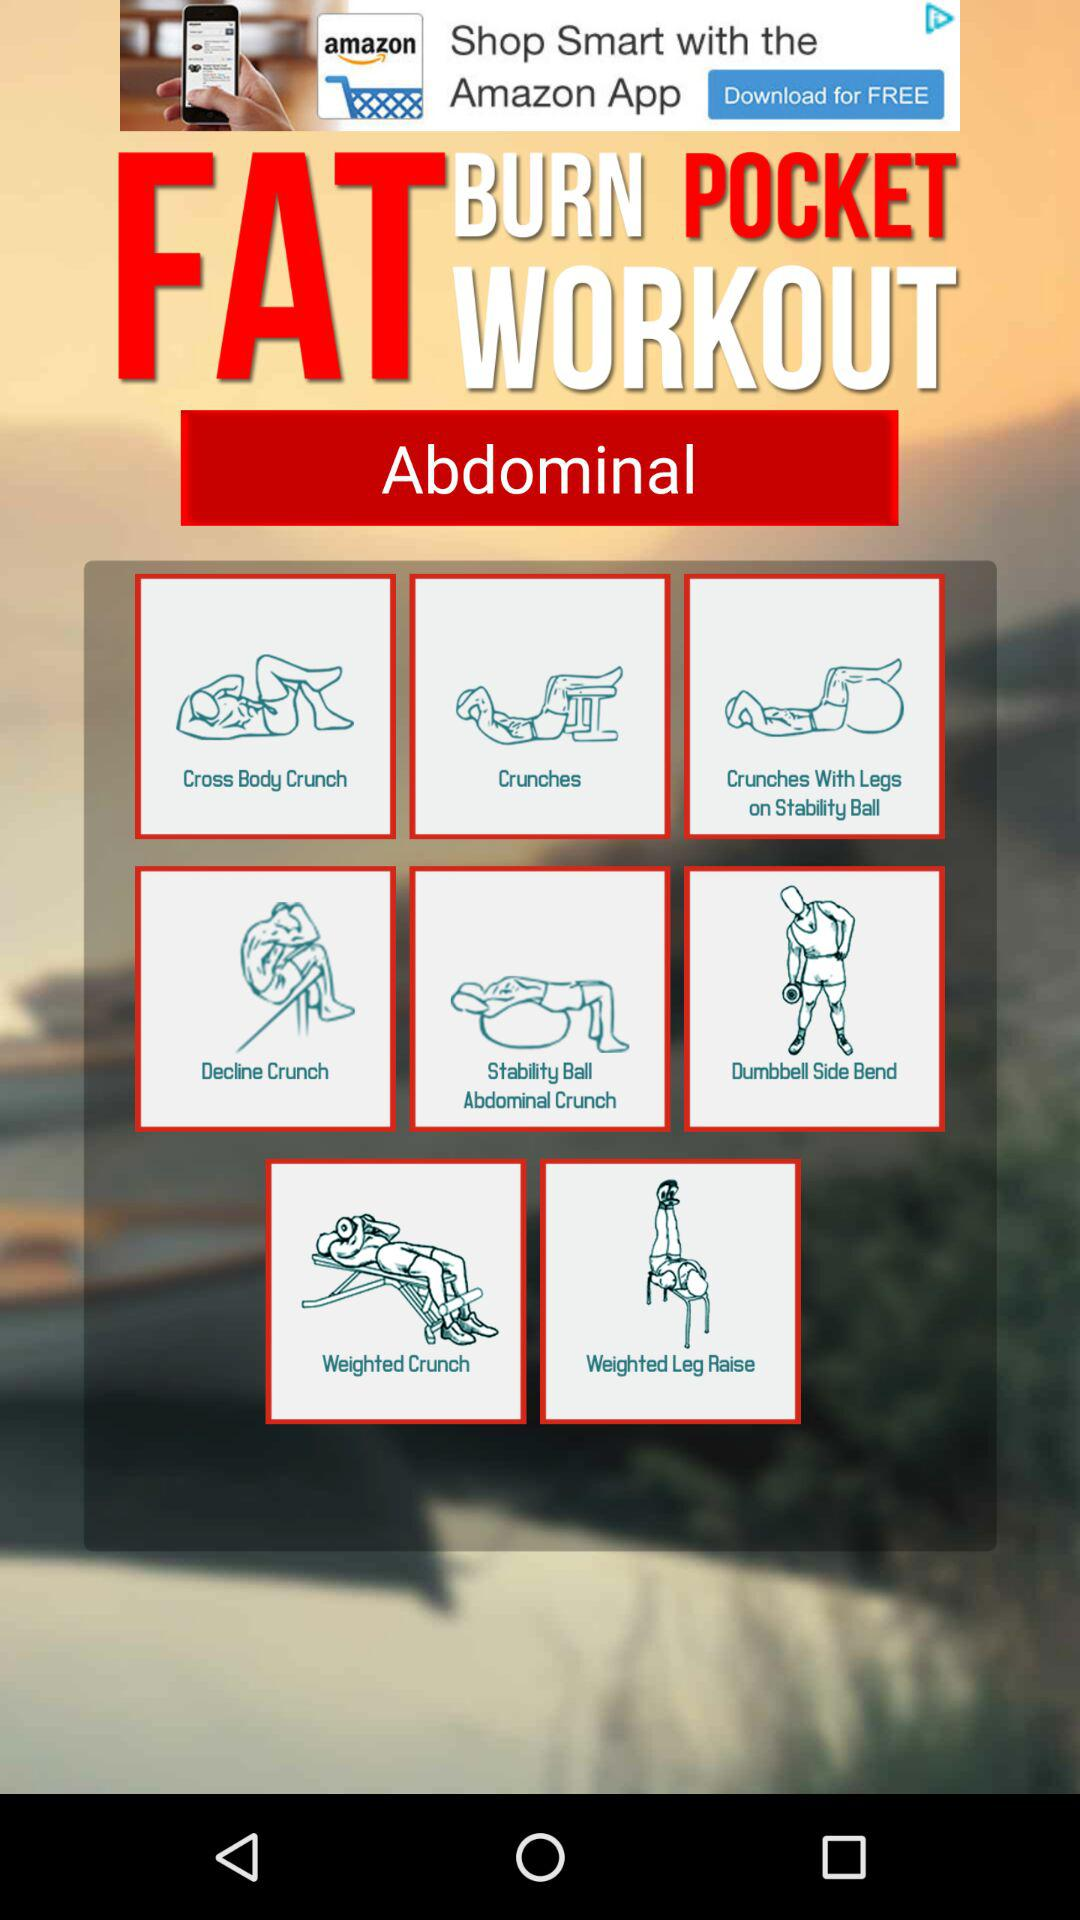How many exercises are in the workout routine?
Answer the question using a single word or phrase. 8 